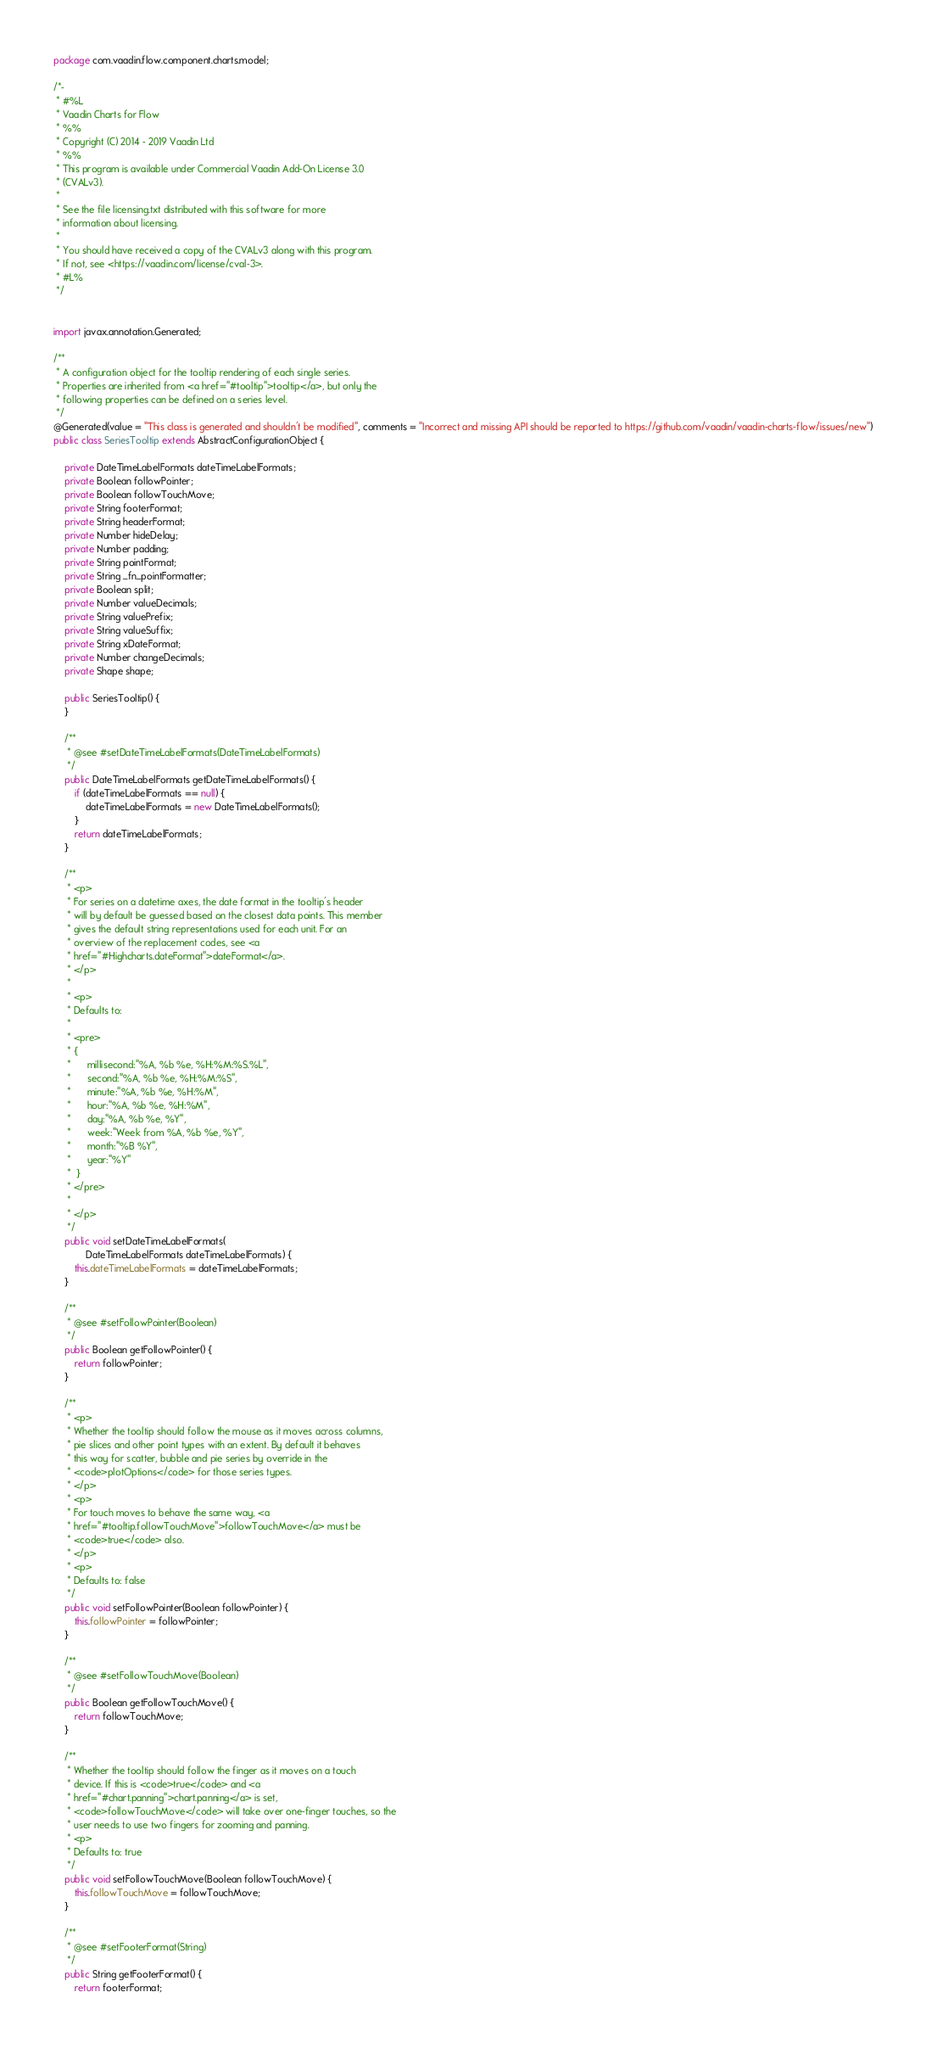<code> <loc_0><loc_0><loc_500><loc_500><_Java_>package com.vaadin.flow.component.charts.model;

/*-
 * #%L
 * Vaadin Charts for Flow
 * %%
 * Copyright (C) 2014 - 2019 Vaadin Ltd
 * %%
 * This program is available under Commercial Vaadin Add-On License 3.0
 * (CVALv3).
 * 
 * See the file licensing.txt distributed with this software for more
 * information about licensing.
 * 
 * You should have received a copy of the CVALv3 along with this program.
 * If not, see <https://vaadin.com/license/cval-3>.
 * #L%
 */


import javax.annotation.Generated;

/**
 * A configuration object for the tooltip rendering of each single series.
 * Properties are inherited from <a href="#tooltip">tooltip</a>, but only the
 * following properties can be defined on a series level.
 */
@Generated(value = "This class is generated and shouldn't be modified", comments = "Incorrect and missing API should be reported to https://github.com/vaadin/vaadin-charts-flow/issues/new")
public class SeriesTooltip extends AbstractConfigurationObject {

	private DateTimeLabelFormats dateTimeLabelFormats;
	private Boolean followPointer;
	private Boolean followTouchMove;
	private String footerFormat;
	private String headerFormat;
	private Number hideDelay;
	private Number padding;
	private String pointFormat;
	private String _fn_pointFormatter;
	private Boolean split;
	private Number valueDecimals;
	private String valuePrefix;
	private String valueSuffix;
	private String xDateFormat;
	private Number changeDecimals;
	private Shape shape;

	public SeriesTooltip() {
	}

	/**
	 * @see #setDateTimeLabelFormats(DateTimeLabelFormats)
	 */
	public DateTimeLabelFormats getDateTimeLabelFormats() {
		if (dateTimeLabelFormats == null) {
			dateTimeLabelFormats = new DateTimeLabelFormats();
		}
		return dateTimeLabelFormats;
	}

	/**
	 * <p>
	 * For series on a datetime axes, the date format in the tooltip's header
	 * will by default be guessed based on the closest data points. This member
	 * gives the default string representations used for each unit. For an
	 * overview of the replacement codes, see <a
	 * href="#Highcharts.dateFormat">dateFormat</a>.
	 * </p>
	 * 
	 * <p>
	 * Defaults to:
	 * 
	 * <pre>
	 * {
	 * 	    millisecond:"%A, %b %e, %H:%M:%S.%L",
	 * 	    second:"%A, %b %e, %H:%M:%S",
	 * 	    minute:"%A, %b %e, %H:%M",
	 * 	    hour:"%A, %b %e, %H:%M",
	 * 	    day:"%A, %b %e, %Y",
	 * 	    week:"Week from %A, %b %e, %Y",
	 * 	    month:"%B %Y",
	 * 	    year:"%Y"
	 * 	}
	 * </pre>
	 * 
	 * </p>
	 */
	public void setDateTimeLabelFormats(
			DateTimeLabelFormats dateTimeLabelFormats) {
		this.dateTimeLabelFormats = dateTimeLabelFormats;
	}

	/**
	 * @see #setFollowPointer(Boolean)
	 */
	public Boolean getFollowPointer() {
		return followPointer;
	}

	/**
	 * <p>
	 * Whether the tooltip should follow the mouse as it moves across columns,
	 * pie slices and other point types with an extent. By default it behaves
	 * this way for scatter, bubble and pie series by override in the
	 * <code>plotOptions</code> for those series types.
	 * </p>
	 * <p>
	 * For touch moves to behave the same way, <a
	 * href="#tooltip.followTouchMove">followTouchMove</a> must be
	 * <code>true</code> also.
	 * </p>
	 * <p>
	 * Defaults to: false
	 */
	public void setFollowPointer(Boolean followPointer) {
		this.followPointer = followPointer;
	}

	/**
	 * @see #setFollowTouchMove(Boolean)
	 */
	public Boolean getFollowTouchMove() {
		return followTouchMove;
	}

	/**
	 * Whether the tooltip should follow the finger as it moves on a touch
	 * device. If this is <code>true</code> and <a
	 * href="#chart.panning">chart.panning</a> is set,
	 * <code>followTouchMove</code> will take over one-finger touches, so the
	 * user needs to use two fingers for zooming and panning.
	 * <p>
	 * Defaults to: true
	 */
	public void setFollowTouchMove(Boolean followTouchMove) {
		this.followTouchMove = followTouchMove;
	}

	/**
	 * @see #setFooterFormat(String)
	 */
	public String getFooterFormat() {
		return footerFormat;</code> 